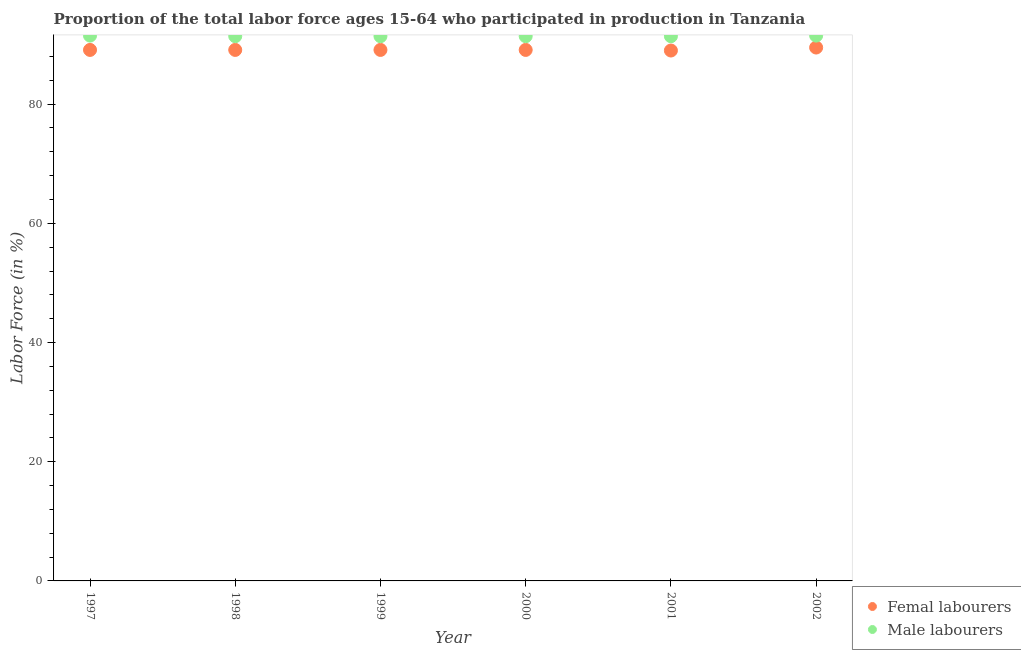What is the percentage of female labor force in 2000?
Provide a short and direct response. 89.1. Across all years, what is the maximum percentage of male labour force?
Keep it short and to the point. 91.5. Across all years, what is the minimum percentage of female labor force?
Provide a succinct answer. 89. In which year was the percentage of male labour force maximum?
Offer a terse response. 1997. In which year was the percentage of male labour force minimum?
Your answer should be very brief. 1998. What is the total percentage of female labor force in the graph?
Give a very brief answer. 534.9. What is the difference between the percentage of female labor force in 1997 and that in 2002?
Keep it short and to the point. -0.4. What is the difference between the percentage of female labor force in 2000 and the percentage of male labour force in 1998?
Keep it short and to the point. -2.3. What is the average percentage of female labor force per year?
Offer a very short reply. 89.15. In the year 1998, what is the difference between the percentage of female labor force and percentage of male labour force?
Your answer should be compact. -2.3. What is the ratio of the percentage of male labour force in 1998 to that in 1999?
Offer a terse response. 1. Is the difference between the percentage of female labor force in 1999 and 2001 greater than the difference between the percentage of male labour force in 1999 and 2001?
Give a very brief answer. Yes. In how many years, is the percentage of female labor force greater than the average percentage of female labor force taken over all years?
Keep it short and to the point. 1. Is the percentage of male labour force strictly greater than the percentage of female labor force over the years?
Keep it short and to the point. Yes. How many years are there in the graph?
Your answer should be very brief. 6. What is the difference between two consecutive major ticks on the Y-axis?
Give a very brief answer. 20. Are the values on the major ticks of Y-axis written in scientific E-notation?
Keep it short and to the point. No. Does the graph contain grids?
Keep it short and to the point. No. Where does the legend appear in the graph?
Provide a short and direct response. Bottom right. How are the legend labels stacked?
Provide a short and direct response. Vertical. What is the title of the graph?
Give a very brief answer. Proportion of the total labor force ages 15-64 who participated in production in Tanzania. Does "Lower secondary rate" appear as one of the legend labels in the graph?
Keep it short and to the point. No. What is the label or title of the X-axis?
Provide a succinct answer. Year. What is the label or title of the Y-axis?
Offer a terse response. Labor Force (in %). What is the Labor Force (in %) of Femal labourers in 1997?
Your response must be concise. 89.1. What is the Labor Force (in %) of Male labourers in 1997?
Offer a very short reply. 91.5. What is the Labor Force (in %) of Femal labourers in 1998?
Offer a very short reply. 89.1. What is the Labor Force (in %) of Male labourers in 1998?
Your answer should be compact. 91.4. What is the Labor Force (in %) in Femal labourers in 1999?
Ensure brevity in your answer.  89.1. What is the Labor Force (in %) of Male labourers in 1999?
Keep it short and to the point. 91.4. What is the Labor Force (in %) of Femal labourers in 2000?
Make the answer very short. 89.1. What is the Labor Force (in %) in Male labourers in 2000?
Your response must be concise. 91.4. What is the Labor Force (in %) in Femal labourers in 2001?
Ensure brevity in your answer.  89. What is the Labor Force (in %) in Male labourers in 2001?
Your response must be concise. 91.4. What is the Labor Force (in %) in Femal labourers in 2002?
Make the answer very short. 89.5. What is the Labor Force (in %) of Male labourers in 2002?
Offer a terse response. 91.5. Across all years, what is the maximum Labor Force (in %) in Femal labourers?
Your response must be concise. 89.5. Across all years, what is the maximum Labor Force (in %) in Male labourers?
Keep it short and to the point. 91.5. Across all years, what is the minimum Labor Force (in %) in Femal labourers?
Provide a short and direct response. 89. Across all years, what is the minimum Labor Force (in %) of Male labourers?
Your answer should be very brief. 91.4. What is the total Labor Force (in %) of Femal labourers in the graph?
Your response must be concise. 534.9. What is the total Labor Force (in %) of Male labourers in the graph?
Give a very brief answer. 548.6. What is the difference between the Labor Force (in %) of Male labourers in 1997 and that in 1998?
Offer a very short reply. 0.1. What is the difference between the Labor Force (in %) in Femal labourers in 1997 and that in 1999?
Your response must be concise. 0. What is the difference between the Labor Force (in %) of Male labourers in 1997 and that in 1999?
Your answer should be compact. 0.1. What is the difference between the Labor Force (in %) of Femal labourers in 1997 and that in 2000?
Offer a very short reply. 0. What is the difference between the Labor Force (in %) of Male labourers in 1997 and that in 2000?
Your answer should be very brief. 0.1. What is the difference between the Labor Force (in %) of Male labourers in 1997 and that in 2001?
Your answer should be compact. 0.1. What is the difference between the Labor Force (in %) in Femal labourers in 1997 and that in 2002?
Give a very brief answer. -0.4. What is the difference between the Labor Force (in %) in Femal labourers in 1998 and that in 1999?
Make the answer very short. 0. What is the difference between the Labor Force (in %) of Femal labourers in 1998 and that in 2000?
Keep it short and to the point. 0. What is the difference between the Labor Force (in %) of Male labourers in 1998 and that in 2000?
Provide a short and direct response. 0. What is the difference between the Labor Force (in %) in Male labourers in 1998 and that in 2001?
Give a very brief answer. 0. What is the difference between the Labor Force (in %) in Male labourers in 1999 and that in 2001?
Offer a very short reply. 0. What is the difference between the Labor Force (in %) of Male labourers in 1999 and that in 2002?
Your answer should be very brief. -0.1. What is the difference between the Labor Force (in %) of Femal labourers in 2000 and that in 2001?
Offer a very short reply. 0.1. What is the difference between the Labor Force (in %) of Male labourers in 2000 and that in 2001?
Provide a short and direct response. 0. What is the difference between the Labor Force (in %) in Male labourers in 2000 and that in 2002?
Provide a succinct answer. -0.1. What is the difference between the Labor Force (in %) in Femal labourers in 1997 and the Labor Force (in %) in Male labourers in 1999?
Your response must be concise. -2.3. What is the difference between the Labor Force (in %) in Femal labourers in 1997 and the Labor Force (in %) in Male labourers in 2000?
Your response must be concise. -2.3. What is the difference between the Labor Force (in %) in Femal labourers in 1997 and the Labor Force (in %) in Male labourers in 2002?
Provide a short and direct response. -2.4. What is the difference between the Labor Force (in %) of Femal labourers in 1998 and the Labor Force (in %) of Male labourers in 2000?
Your response must be concise. -2.3. What is the difference between the Labor Force (in %) in Femal labourers in 1998 and the Labor Force (in %) in Male labourers in 2001?
Offer a terse response. -2.3. What is the difference between the Labor Force (in %) of Femal labourers in 1998 and the Labor Force (in %) of Male labourers in 2002?
Offer a very short reply. -2.4. What is the difference between the Labor Force (in %) in Femal labourers in 2000 and the Labor Force (in %) in Male labourers in 2001?
Your answer should be very brief. -2.3. What is the difference between the Labor Force (in %) in Femal labourers in 2001 and the Labor Force (in %) in Male labourers in 2002?
Give a very brief answer. -2.5. What is the average Labor Force (in %) in Femal labourers per year?
Your answer should be compact. 89.15. What is the average Labor Force (in %) of Male labourers per year?
Your answer should be compact. 91.43. In the year 2001, what is the difference between the Labor Force (in %) in Femal labourers and Labor Force (in %) in Male labourers?
Offer a terse response. -2.4. What is the ratio of the Labor Force (in %) in Femal labourers in 1997 to that in 1998?
Your answer should be compact. 1. What is the ratio of the Labor Force (in %) in Male labourers in 1997 to that in 1998?
Your answer should be compact. 1. What is the ratio of the Labor Force (in %) of Femal labourers in 1997 to that in 1999?
Provide a short and direct response. 1. What is the ratio of the Labor Force (in %) of Male labourers in 1997 to that in 2001?
Provide a succinct answer. 1. What is the ratio of the Labor Force (in %) in Femal labourers in 1998 to that in 1999?
Offer a very short reply. 1. What is the ratio of the Labor Force (in %) of Male labourers in 1998 to that in 2000?
Offer a terse response. 1. What is the ratio of the Labor Force (in %) of Femal labourers in 1998 to that in 2001?
Keep it short and to the point. 1. What is the ratio of the Labor Force (in %) of Male labourers in 1998 to that in 2002?
Give a very brief answer. 1. What is the ratio of the Labor Force (in %) of Male labourers in 1999 to that in 2000?
Offer a terse response. 1. 